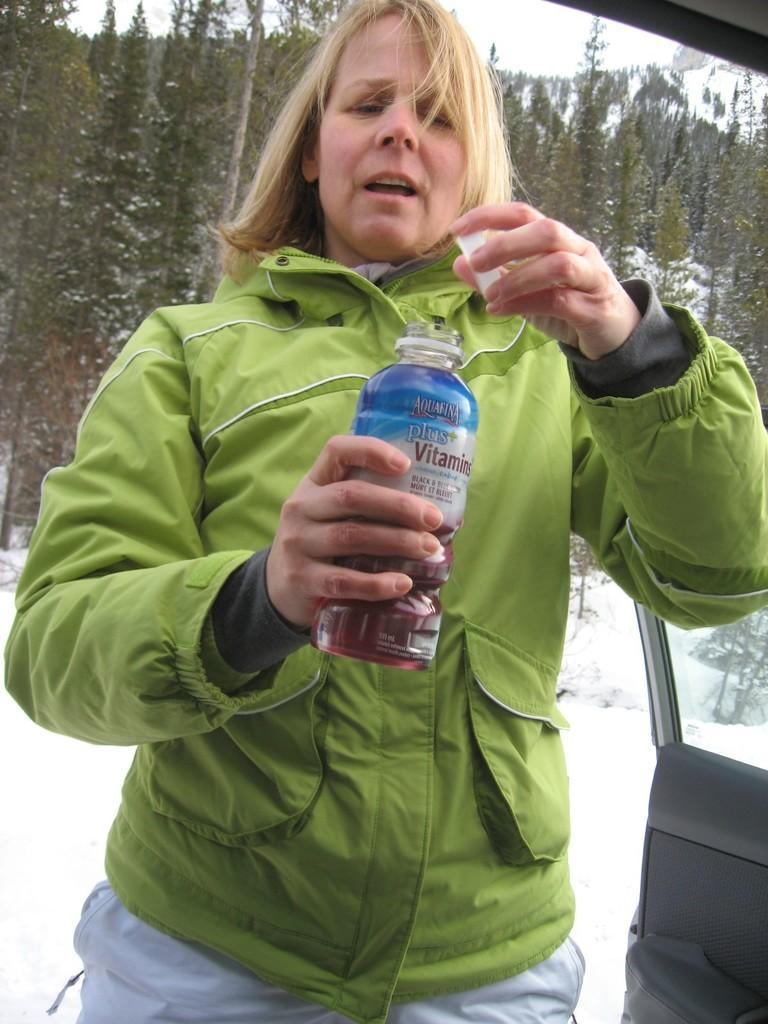Could you give a brief overview of what you see in this image? In this image I see a woman who is holding a bottle, In the background I see the snow and the trees. 